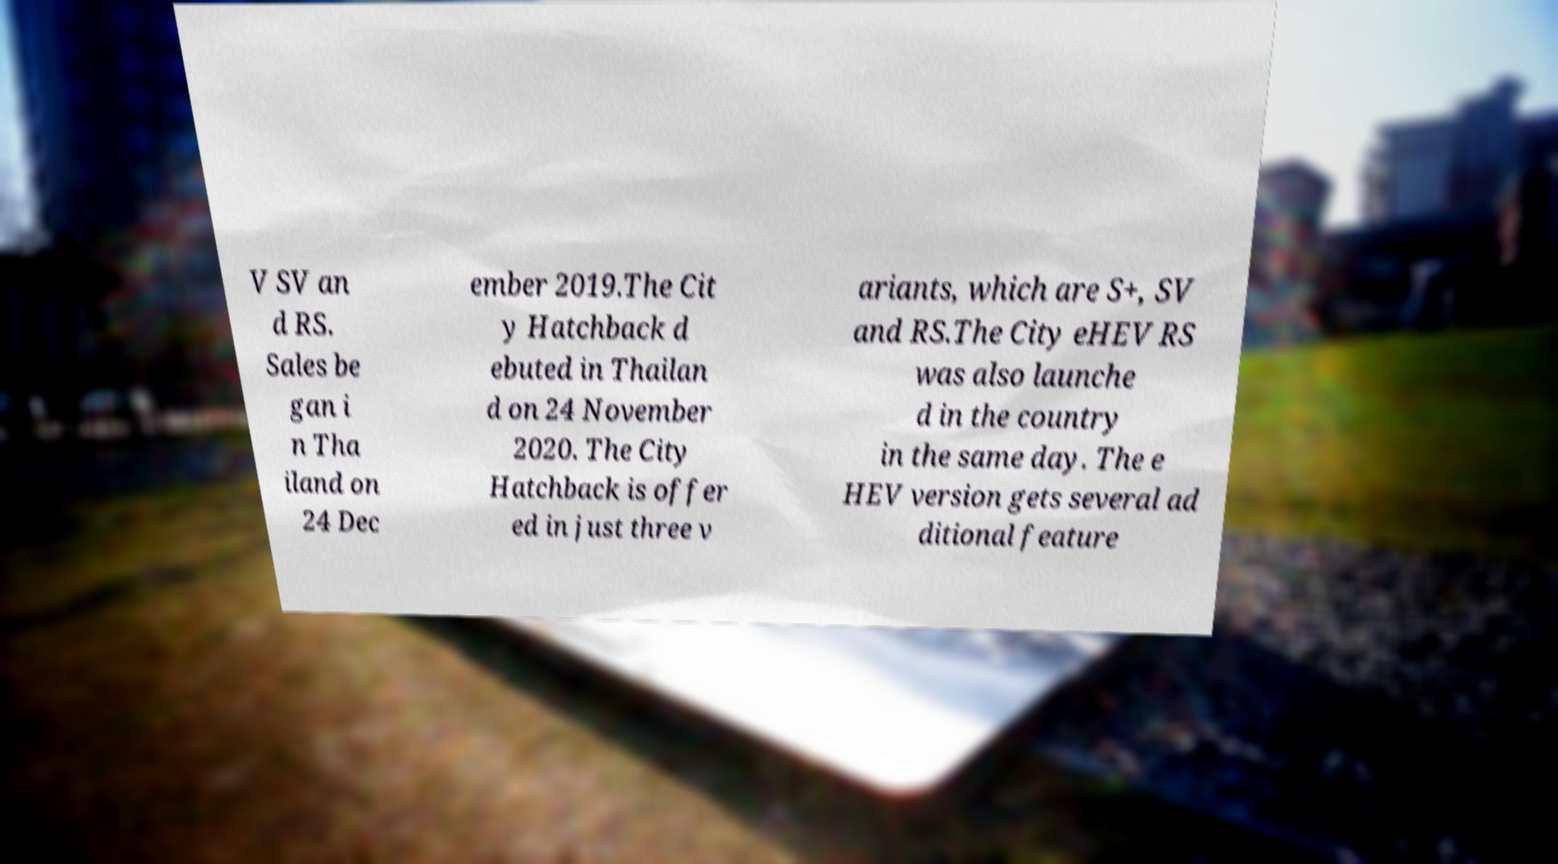There's text embedded in this image that I need extracted. Can you transcribe it verbatim? V SV an d RS. Sales be gan i n Tha iland on 24 Dec ember 2019.The Cit y Hatchback d ebuted in Thailan d on 24 November 2020. The City Hatchback is offer ed in just three v ariants, which are S+, SV and RS.The City eHEV RS was also launche d in the country in the same day. The e HEV version gets several ad ditional feature 